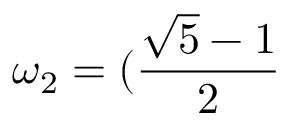<formula> <loc_0><loc_0><loc_500><loc_500>\omega _ { 2 } = ( \frac { \sqrt { 5 } - 1 } { 2 }</formula> 